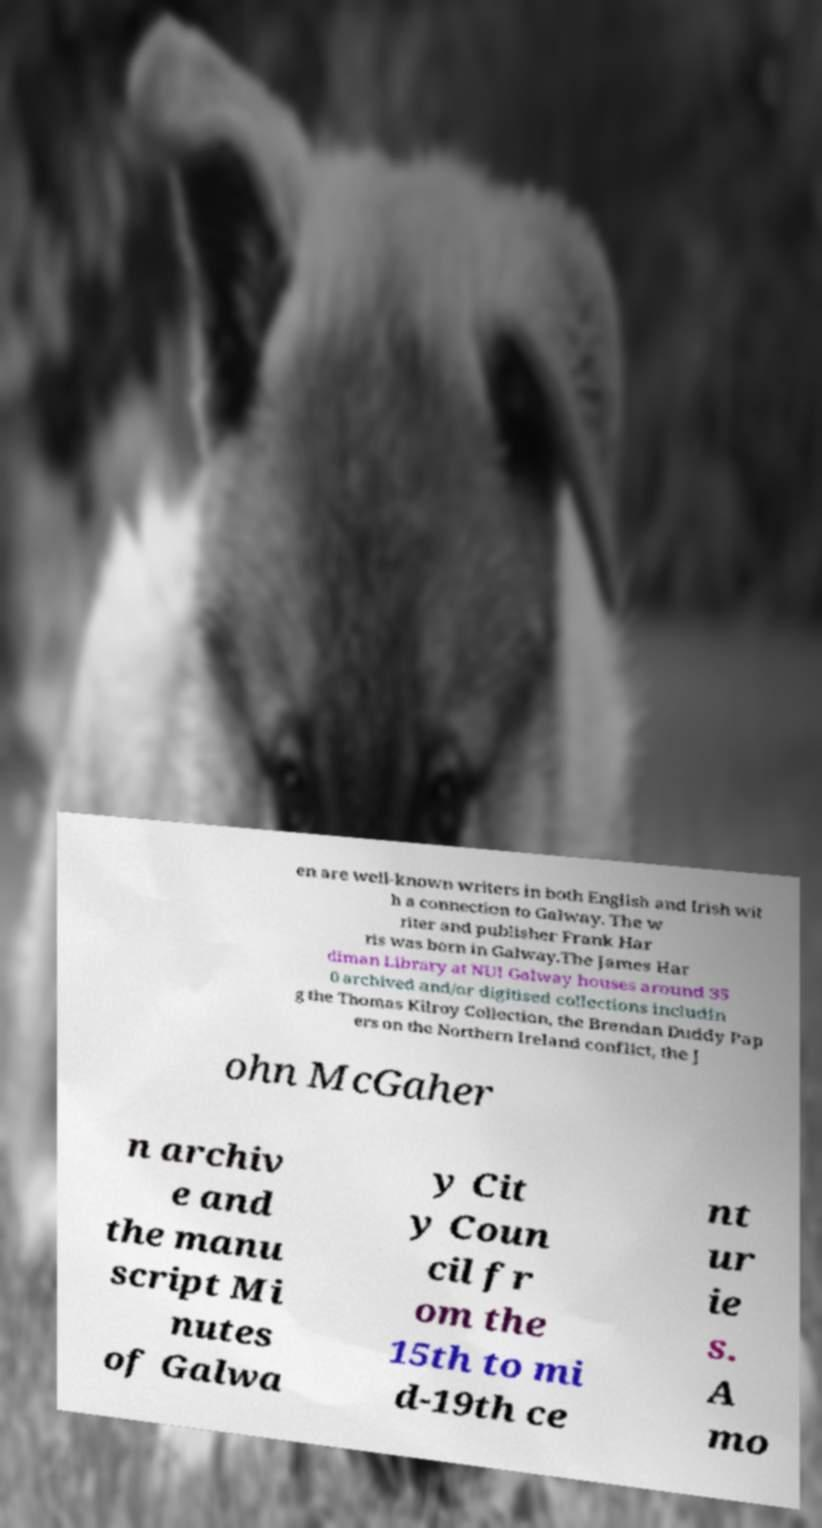I need the written content from this picture converted into text. Can you do that? en are well-known writers in both English and Irish wit h a connection to Galway. The w riter and publisher Frank Har ris was born in Galway.The James Har diman Library at NUI Galway houses around 35 0 archived and/or digitised collections includin g the Thomas Kilroy Collection, the Brendan Duddy Pap ers on the Northern Ireland conflict, the J ohn McGaher n archiv e and the manu script Mi nutes of Galwa y Cit y Coun cil fr om the 15th to mi d-19th ce nt ur ie s. A mo 